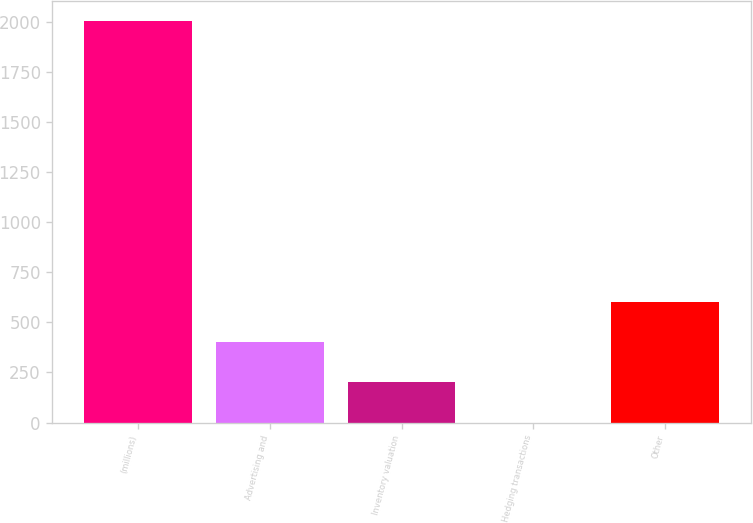Convert chart. <chart><loc_0><loc_0><loc_500><loc_500><bar_chart><fcel>(millions)<fcel>Advertising and<fcel>Inventory valuation<fcel>Hedging transactions<fcel>Other<nl><fcel>2005<fcel>401.08<fcel>200.59<fcel>0.1<fcel>601.57<nl></chart> 